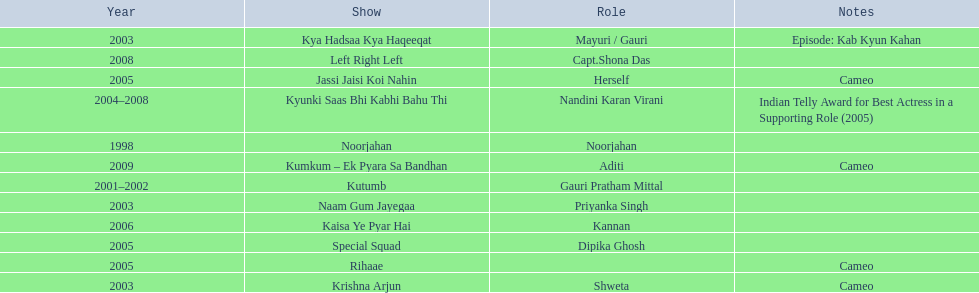What shows has gauri pradhan tejwani been in? Noorjahan, Kutumb, Krishna Arjun, Naam Gum Jayegaa, Kya Hadsaa Kya Haqeeqat, Kyunki Saas Bhi Kabhi Bahu Thi, Rihaae, Jassi Jaisi Koi Nahin, Special Squad, Kaisa Ye Pyar Hai, Left Right Left, Kumkum – Ek Pyara Sa Bandhan. Would you be able to parse every entry in this table? {'header': ['Year', 'Show', 'Role', 'Notes'], 'rows': [['2003', 'Kya Hadsaa Kya Haqeeqat', 'Mayuri / Gauri', 'Episode: Kab Kyun Kahan'], ['2008', 'Left Right Left', 'Capt.Shona Das', ''], ['2005', 'Jassi Jaisi Koi Nahin', 'Herself', 'Cameo'], ['2004–2008', 'Kyunki Saas Bhi Kabhi Bahu Thi', 'Nandini Karan Virani', 'Indian Telly Award for Best Actress in a Supporting Role (2005)'], ['1998', 'Noorjahan', 'Noorjahan', ''], ['2009', 'Kumkum – Ek Pyara Sa Bandhan', 'Aditi', 'Cameo'], ['2001–2002', 'Kutumb', 'Gauri Pratham Mittal', ''], ['2003', 'Naam Gum Jayegaa', 'Priyanka Singh', ''], ['2006', 'Kaisa Ye Pyar Hai', 'Kannan', ''], ['2005', 'Special Squad', 'Dipika Ghosh', ''], ['2005', 'Rihaae', '', 'Cameo'], ['2003', 'Krishna Arjun', 'Shweta', 'Cameo']]} Of these shows, which one lasted for more than a year? Kutumb, Kyunki Saas Bhi Kabhi Bahu Thi. Which of these lasted the longest? Kyunki Saas Bhi Kabhi Bahu Thi. 